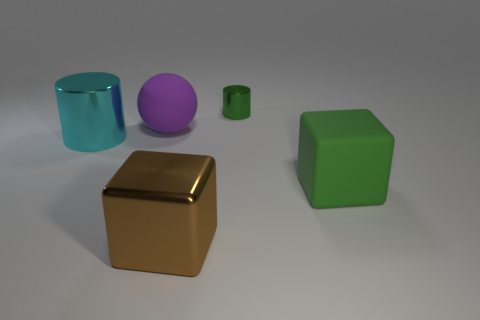There is a metallic block; does it have the same color as the metal cylinder to the right of the large cyan metal thing?
Offer a terse response. No. There is a green thing that is made of the same material as the large brown thing; what is its size?
Offer a terse response. Small. There is another thing that is the same color as the tiny metal object; what size is it?
Make the answer very short. Large. Does the small shiny thing have the same color as the rubber ball?
Give a very brief answer. No. There is a cylinder on the left side of the cylinder that is right of the big purple object; are there any things on the right side of it?
Keep it short and to the point. Yes. What number of other green things are the same size as the green metallic object?
Provide a succinct answer. 0. There is a cylinder that is right of the brown metal cube; does it have the same size as the matte thing behind the cyan object?
Offer a terse response. No. There is a object that is both on the right side of the big cyan metallic thing and on the left side of the large brown block; what is its shape?
Keep it short and to the point. Sphere. Is there a tiny cylinder of the same color as the big cylinder?
Provide a succinct answer. No. Is there a big red shiny object?
Provide a succinct answer. No. 